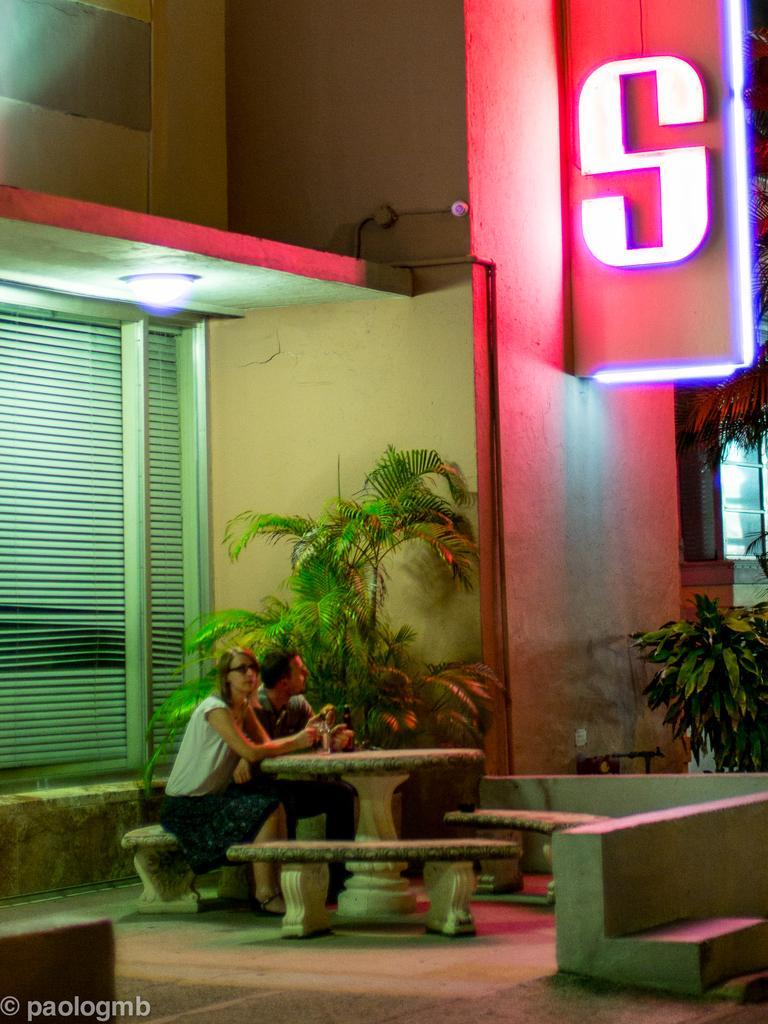Can you describe this image briefly? There are two persons sitting on the bench and in the background we can see a building,plants. 